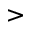Convert formula to latex. <formula><loc_0><loc_0><loc_500><loc_500>></formula> 